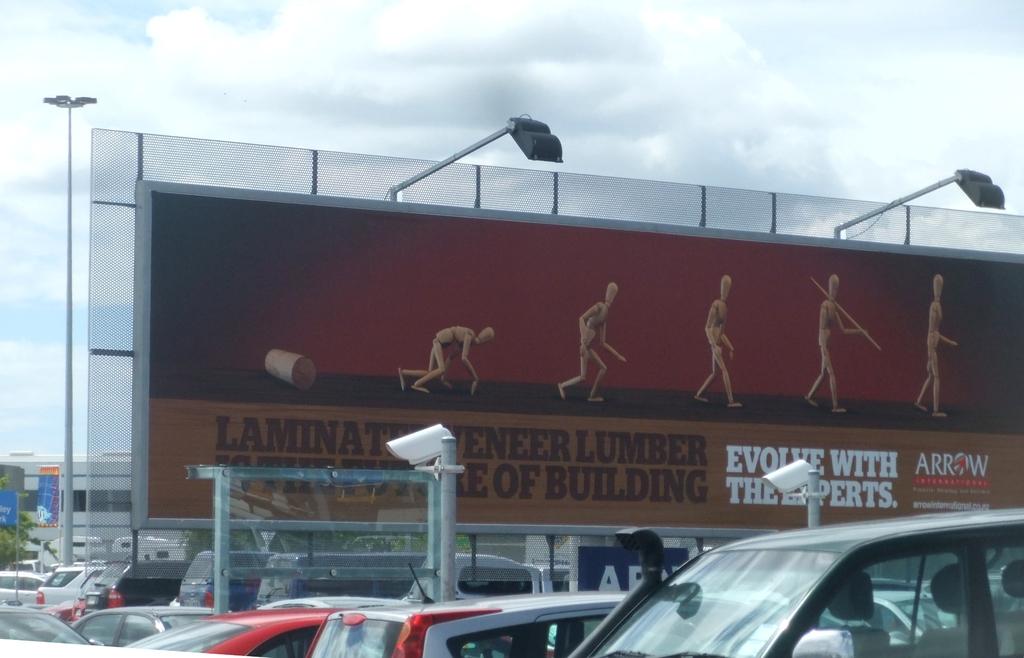This is an advertisement for what laminated veneer wood product?
Provide a succinct answer. Arrow. What kind of material does the company specialize in?
Offer a terse response. Lumber. 